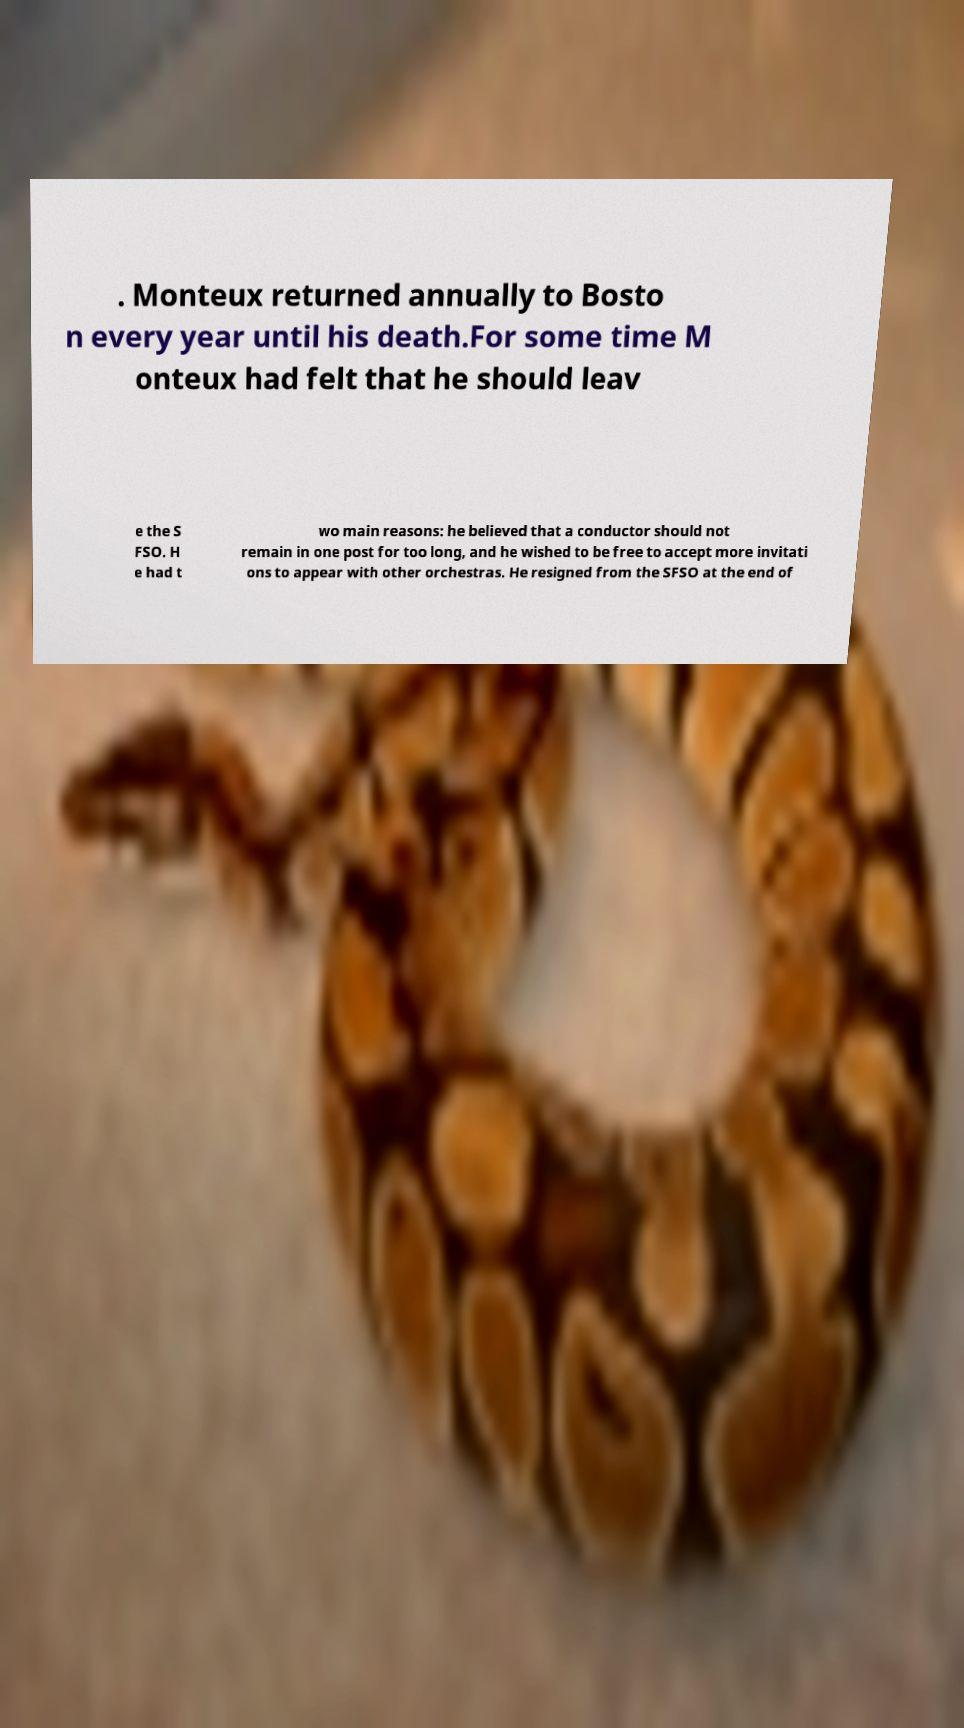Please read and relay the text visible in this image. What does it say? . Monteux returned annually to Bosto n every year until his death.For some time M onteux had felt that he should leav e the S FSO. H e had t wo main reasons: he believed that a conductor should not remain in one post for too long, and he wished to be free to accept more invitati ons to appear with other orchestras. He resigned from the SFSO at the end of 